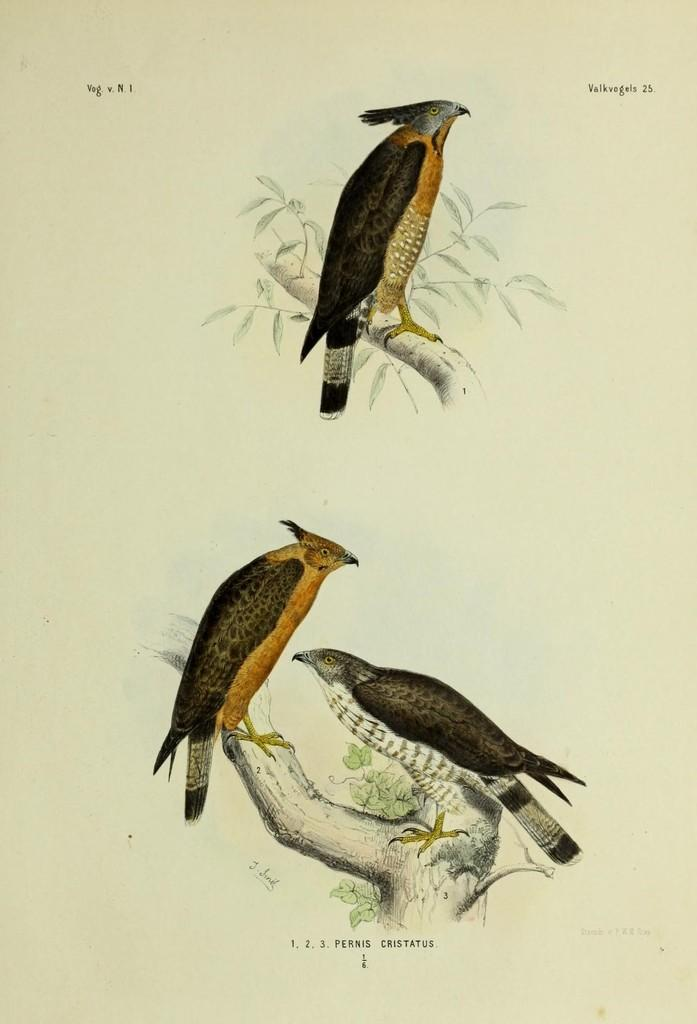How many birds are visible in the image? There are three birds visible in the image. Where are the birds located in the image? Two birds are standing on a tree branch in the center of the image, and another bird is standing on a tree branch at the top of the image. What type of pocket can be seen on the bird in the image? There are no pockets present on the birds in the image, as birds do not have clothing or accessories. 